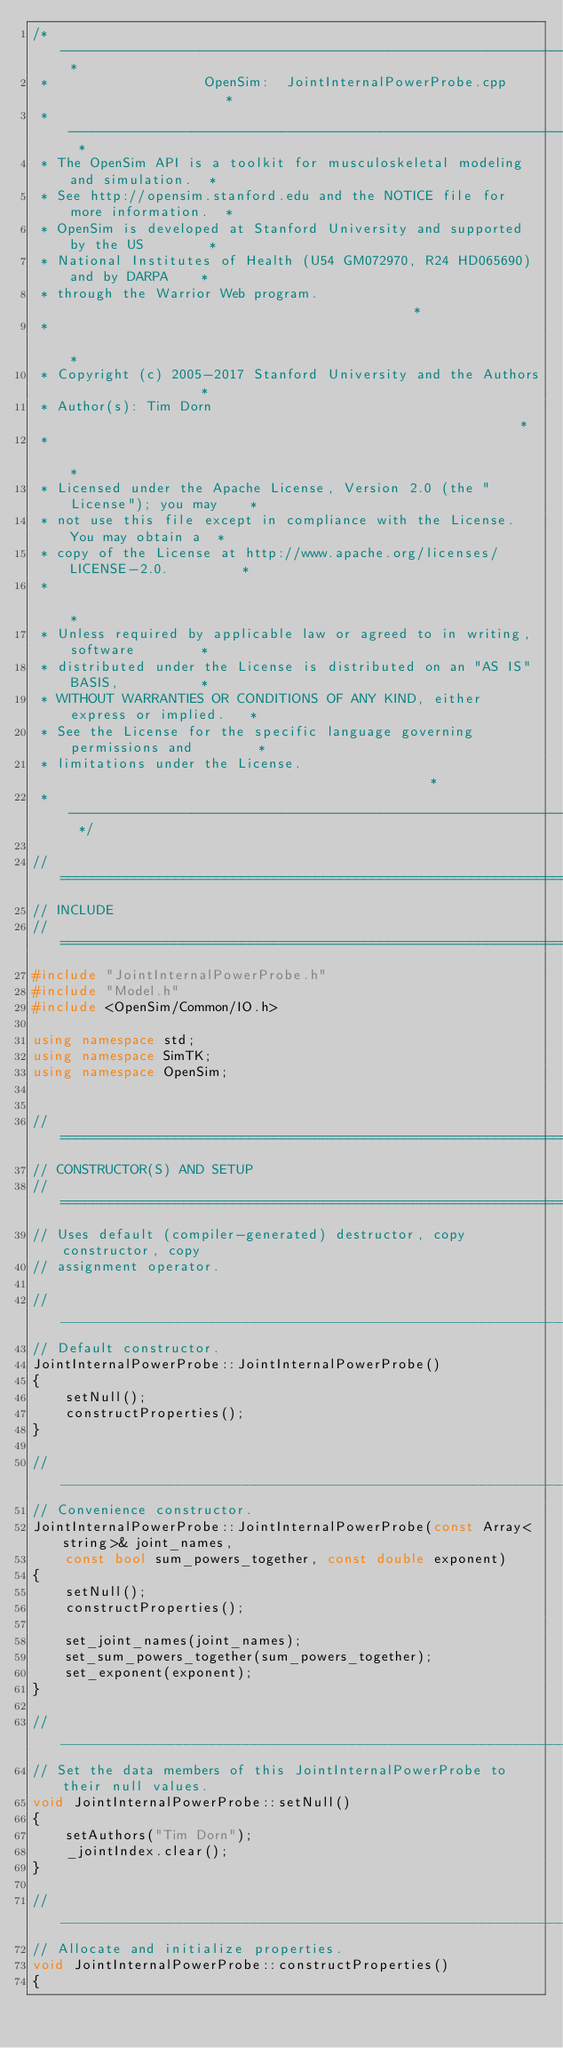Convert code to text. <code><loc_0><loc_0><loc_500><loc_500><_C++_>/* -------------------------------------------------------------------------- *
 *                   OpenSim:  JointInternalPowerProbe.cpp                    *
 * -------------------------------------------------------------------------- *
 * The OpenSim API is a toolkit for musculoskeletal modeling and simulation.  *
 * See http://opensim.stanford.edu and the NOTICE file for more information.  *
 * OpenSim is developed at Stanford University and supported by the US        *
 * National Institutes of Health (U54 GM072970, R24 HD065690) and by DARPA    *
 * through the Warrior Web program.                                           *
 *                                                                            *
 * Copyright (c) 2005-2017 Stanford University and the Authors                *
 * Author(s): Tim Dorn                                                        *
 *                                                                            *
 * Licensed under the Apache License, Version 2.0 (the "License"); you may    *
 * not use this file except in compliance with the License. You may obtain a  *
 * copy of the License at http://www.apache.org/licenses/LICENSE-2.0.         *
 *                                                                            *
 * Unless required by applicable law or agreed to in writing, software        *
 * distributed under the License is distributed on an "AS IS" BASIS,          *
 * WITHOUT WARRANTIES OR CONDITIONS OF ANY KIND, either express or implied.   *
 * See the License for the specific language governing permissions and        *
 * limitations under the License.                                             *
 * -------------------------------------------------------------------------- */

//=============================================================================
// INCLUDE
//=============================================================================
#include "JointInternalPowerProbe.h"
#include "Model.h"
#include <OpenSim/Common/IO.h>

using namespace std;
using namespace SimTK;
using namespace OpenSim;


//=============================================================================
// CONSTRUCTOR(S) AND SETUP
//=============================================================================
// Uses default (compiler-generated) destructor, copy constructor, copy 
// assignment operator.

//_____________________________________________________________________________
// Default constructor.
JointInternalPowerProbe::JointInternalPowerProbe() 
{
    setNull();
    constructProperties();
}

//_____________________________________________________________________________
// Convenience constructor.
JointInternalPowerProbe::JointInternalPowerProbe(const Array<string>& joint_names, 
    const bool sum_powers_together, const double exponent)
{
    setNull();
    constructProperties();

    set_joint_names(joint_names);
    set_sum_powers_together(sum_powers_together);
    set_exponent(exponent);
}

//_____________________________________________________________________________
// Set the data members of this JointInternalPowerProbe to their null values.
void JointInternalPowerProbe::setNull()
{
    setAuthors("Tim Dorn");
    _jointIndex.clear();
}

//_____________________________________________________________________________
// Allocate and initialize properties.
void JointInternalPowerProbe::constructProperties()
{</code> 